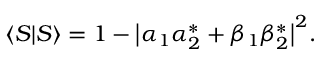<formula> <loc_0><loc_0><loc_500><loc_500>\langle S | S \rangle = 1 - \left | \alpha _ { 1 } \alpha _ { 2 } ^ { * } + \beta _ { 1 } \beta _ { 2 } ^ { * } \right | ^ { 2 } .</formula> 